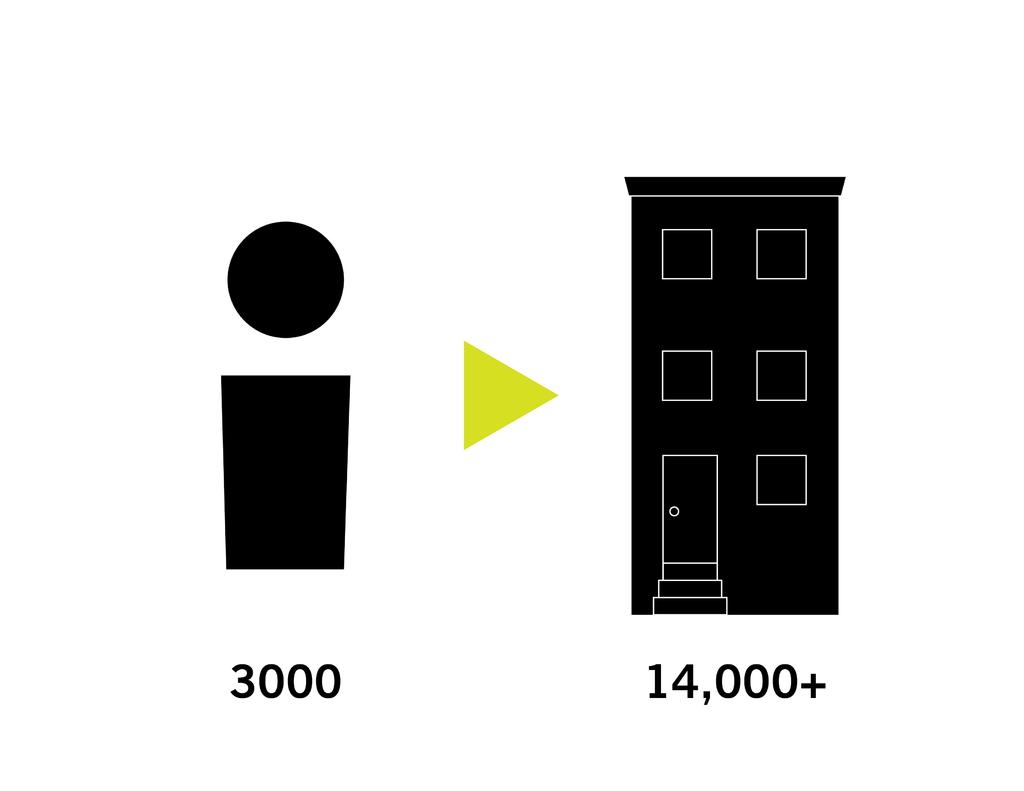<image>
Relay a brief, clear account of the picture shown. a door with the number 14000 at the bottom 